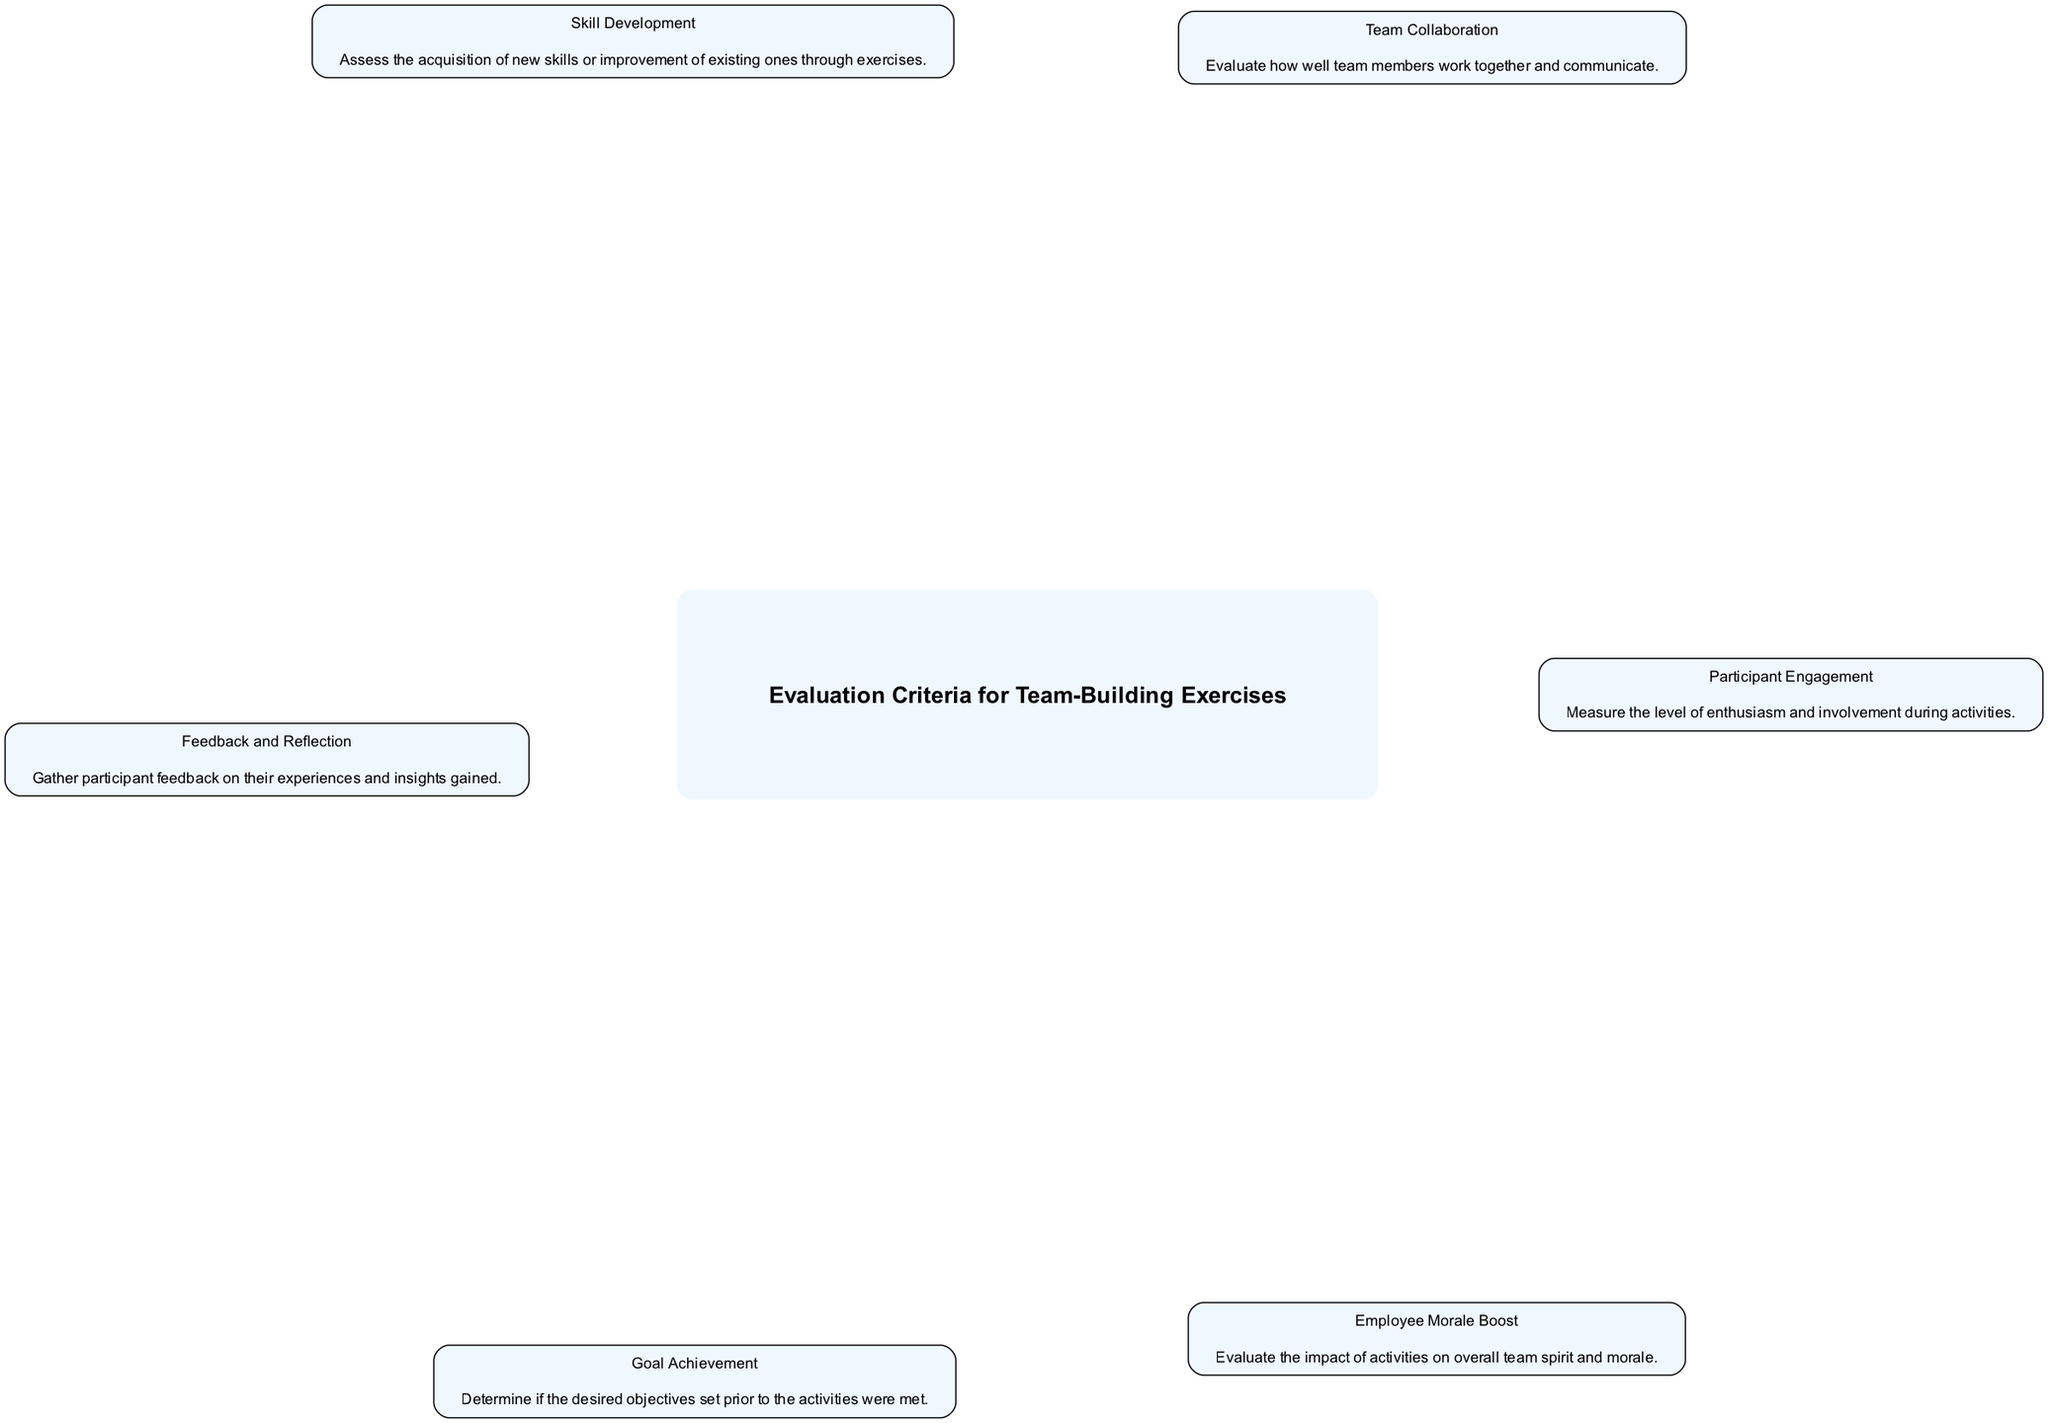What is the first evaluation criterion listed in the diagram? The first evaluation criterion in the provided elements is "Participant Engagement". This is determined by looking at the order of the elements as they are added to the diagram, as the first listed element appears at the top.
Answer: Participant Engagement How many total evaluation criteria are represented in the diagram? The diagram contains a total of six nodes, each representing an evaluation criterion for measuring the success of team-building exercises. This is counted directly from the 'elements' data provided.
Answer: Six Which criterion addresses the communication aspect among team members? The "Team Collaboration" criterion specifically evaluates how well team members work together and communicate, as described in the node's information. This node's label explicitly mentions communication.
Answer: Team Collaboration What does the "Feedback and Reflection" criterion measure? The "Feedback and Reflection" criterion focuses on gathering participant feedback regarding their experiences and insights gained. This is detailed in the description associated with this criterion in the diagram.
Answer: Participant feedback Which two criteria are most likely to directly indicate improvements in team morale? "Employee Morale Boost" and "Goal Achievement" are the two criteria that directly assess improvements in team morale. "Employee Morale Boost" measures overall team spirit, whereas "Goal Achievement" reflects the satisfaction of accomplishing set objectives, which can enhance morale.
Answer: Employee Morale Boost and Goal Achievement What is the relationship between "Skill Development" and "Goal Achievement"? "Skill Development" and "Goal Achievement" are related in that developing new skills can facilitate the achievement of goals set for the team-building exercises. When participants successfully develop skills, they are more likely to meet the goals defined prior to the activities.
Answer: Skills facilitate goal achievement 